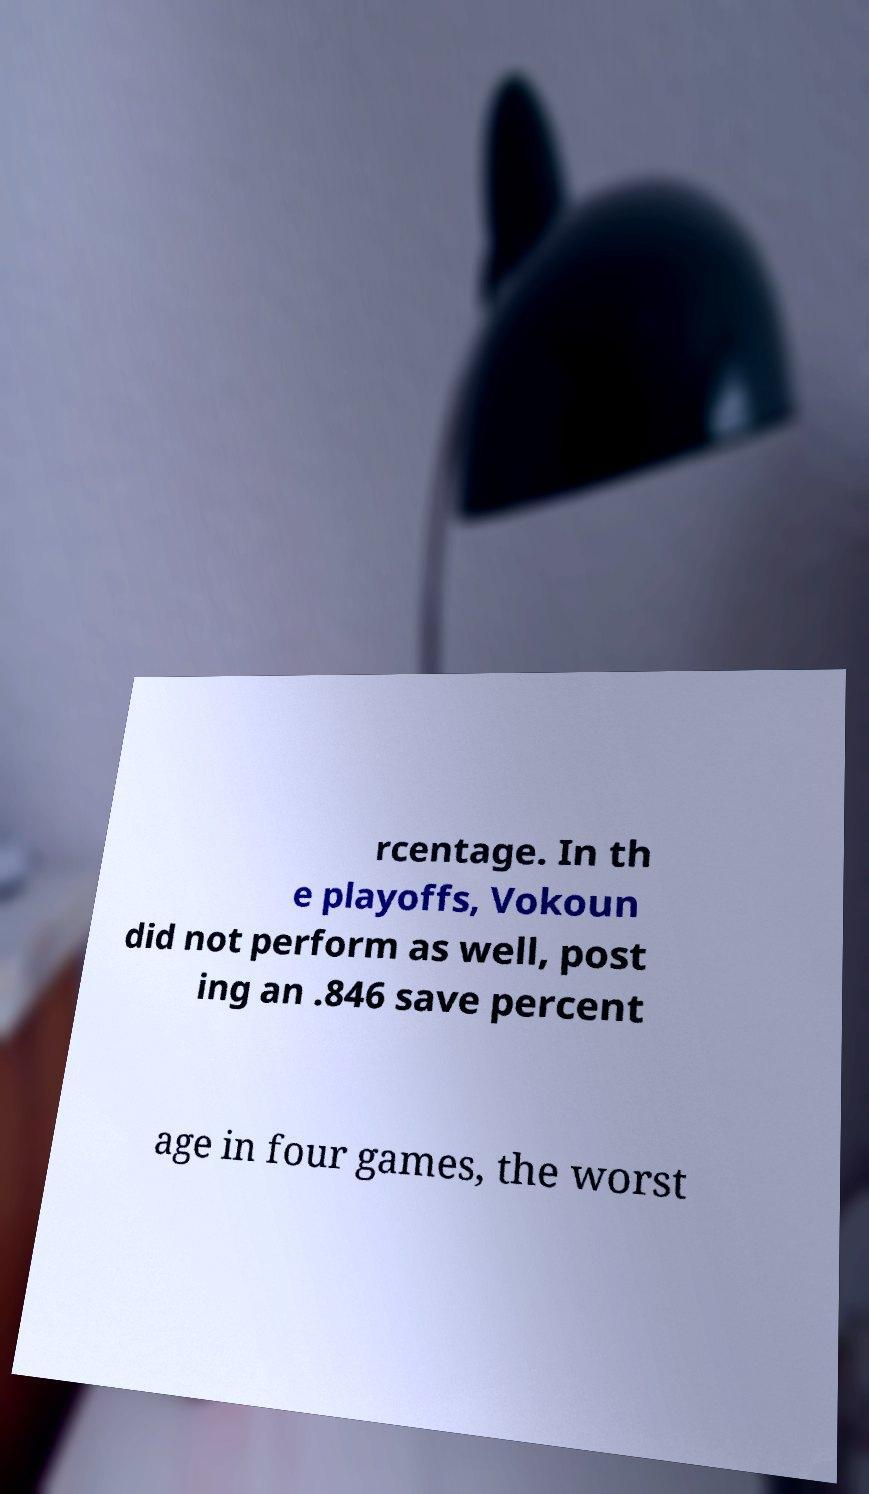Can you accurately transcribe the text from the provided image for me? rcentage. In th e playoffs, Vokoun did not perform as well, post ing an .846 save percent age in four games, the worst 